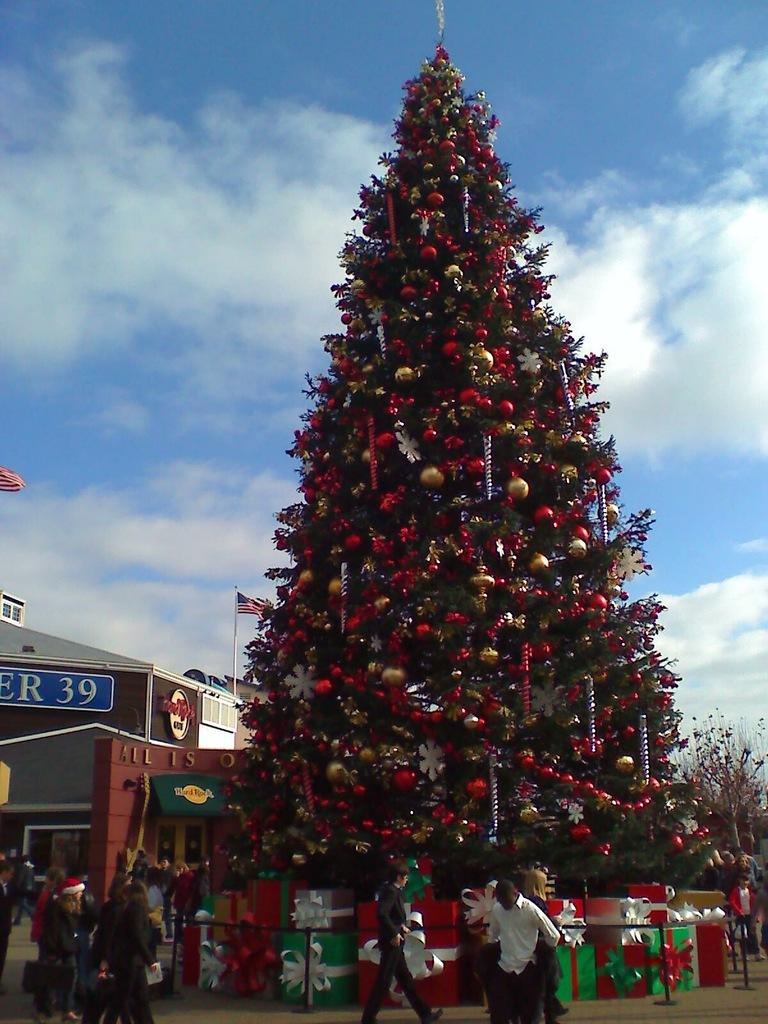What is the main object in the image? There is a Christmas tree in the image. How is the Christmas tree decorated? The Christmas tree is decorated with objects. What can be seen in the background of the image? There is a building, trees, people, and the sky visible in the background of the image. What is the building in the background doing? The building has flags. How many people are standing on the ground in the background of the image? There are people standing on the ground in the background of the image. How many apples are being smashed by the people in the image? There are no apples or smashing activities present in the image. What type of pies are being served at the event in the image? There is no event or pies present in the image. 